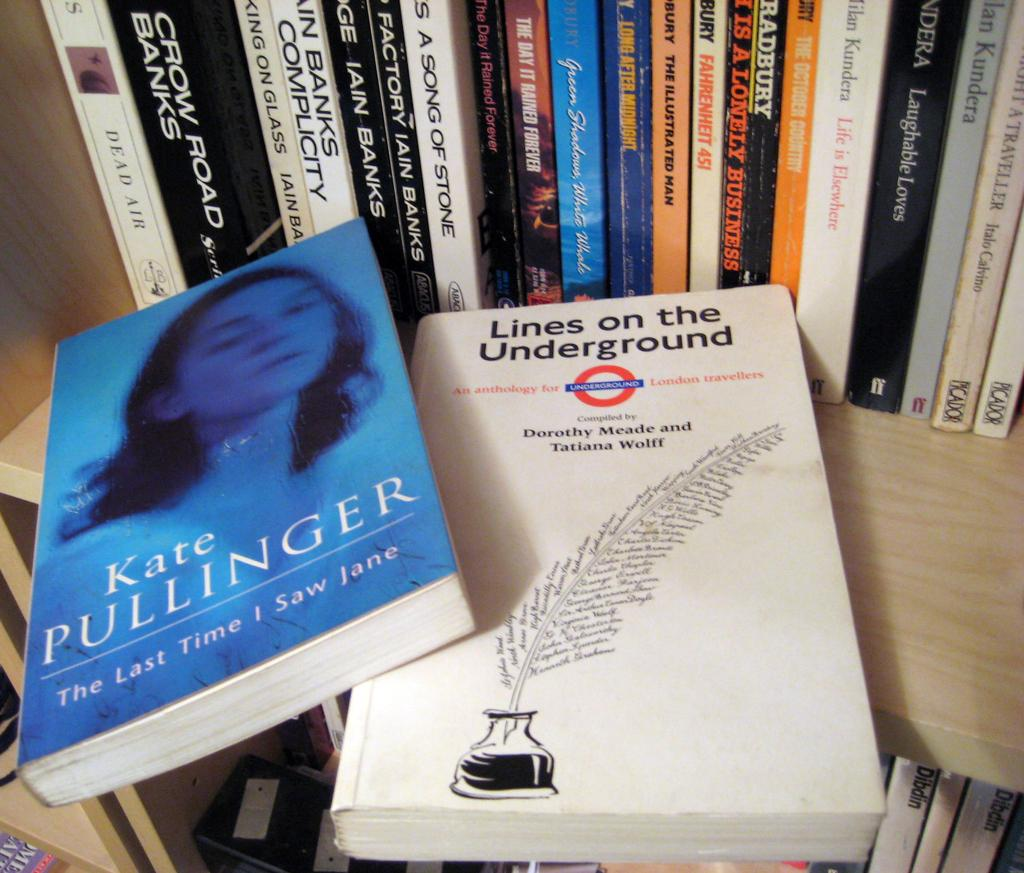Who is present in the image? There is a woman in the image. What can be seen on the shelf in the image? There are books on a shelf in the image. What type of badge is the woman wearing in the image? There is no badge visible on the woman in the image. Can you describe the lamp that is present in the image? There is no lamp present in the image. 